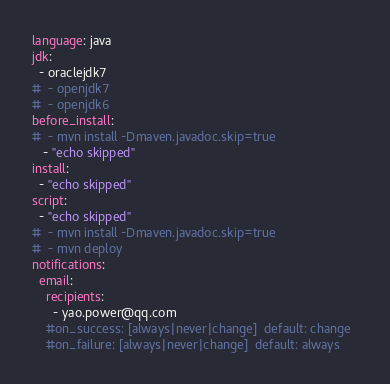Convert code to text. <code><loc_0><loc_0><loc_500><loc_500><_YAML_>language: java  
jdk:  
  - oraclejdk7  
#  - openjdk7  
#  - openjdk6  
before_install:  
#  - mvn install -Dmaven.javadoc.skip=true  
   - "echo skipped"  
install:  
  - "echo skipped"  
script:  
  - "echo skipped"   
#  - mvn install -Dmaven.javadoc.skip=true  
#  - mvn deploy  
notifications:  
  email:  
    recipients:  
      - yao.power@qq.com  
    #on_success: [always|never|change]  default: change  
    #on_failure: [always|never|change]  default: always  
</code> 